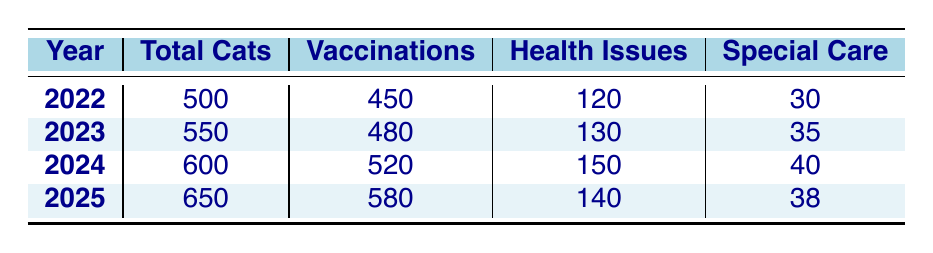What was the total number of cats checked in 2023? The table shows "Total Cats" for 2023 is listed as 550.
Answer: 550 How many vaccinations were administered in 2024? The table states that "Vaccinations" for 2024 is 520.
Answer: 520 Which year had the highest number of cats needing special care? Looking at the "Special Care" column, 2024 has the highest value at 40.
Answer: 2024 What is the difference in the total number of cats checked between 2022 and 2025? The total for 2025 is 650 and for 2022 is 500. The difference is 650 - 500 = 150.
Answer: 150 Did the number of cats with health issues increase every year? Using the "Health Issues" values, they are 120, 130, 150, and 140. The value decreased from 2024 to 2025 (150 to 140), so this statement is false.
Answer: No What percentage of total cats were vaccinated in 2023? The number of vaccinations for 2023 is 480, and the total cats checked is 550. To find the percentage, we calculate (480/550) * 100 ≈ 87.27%.
Answer: 87.27% What trend can be seen in the total number of cats checked from 2022 to 2025? The "Total Cats" figures are increasing: 500 in 2022, 550 in 2023, 600 in 2024, and 650 in 2025, indicating a steady increase each year.
Answer: Steady increase Which year saw the highest number of cats with health issues? The "Health Issues" column shows values of 120, 130, 150, and 140. The highest is in 2024 with 150.
Answer: 2024 How many more vaccinations were given in 2025 compared to 2023? The vaccinations administered in 2025 are 580 and in 2023 are 480. The difference is 580 - 480 = 100.
Answer: 100 Was there a year when the number of cats with health issues was less than 100? Checking the values in the "Health Issues" column, all years have numbers above 100: 120, 130, 150, and 140. So, the answer is false.
Answer: No 